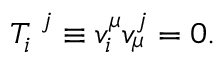Convert formula to latex. <formula><loc_0><loc_0><loc_500><loc_500>T _ { i } ^ { j } \equiv v _ { i } ^ { \mu } v _ { \mu } ^ { j } = 0 .</formula> 